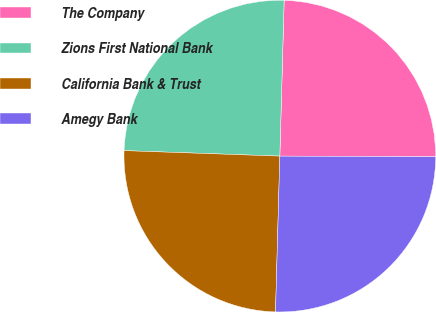Convert chart to OTSL. <chart><loc_0><loc_0><loc_500><loc_500><pie_chart><fcel>The Company<fcel>Zions First National Bank<fcel>California Bank & Trust<fcel>Amegy Bank<nl><fcel>24.63%<fcel>24.88%<fcel>25.12%<fcel>25.37%<nl></chart> 